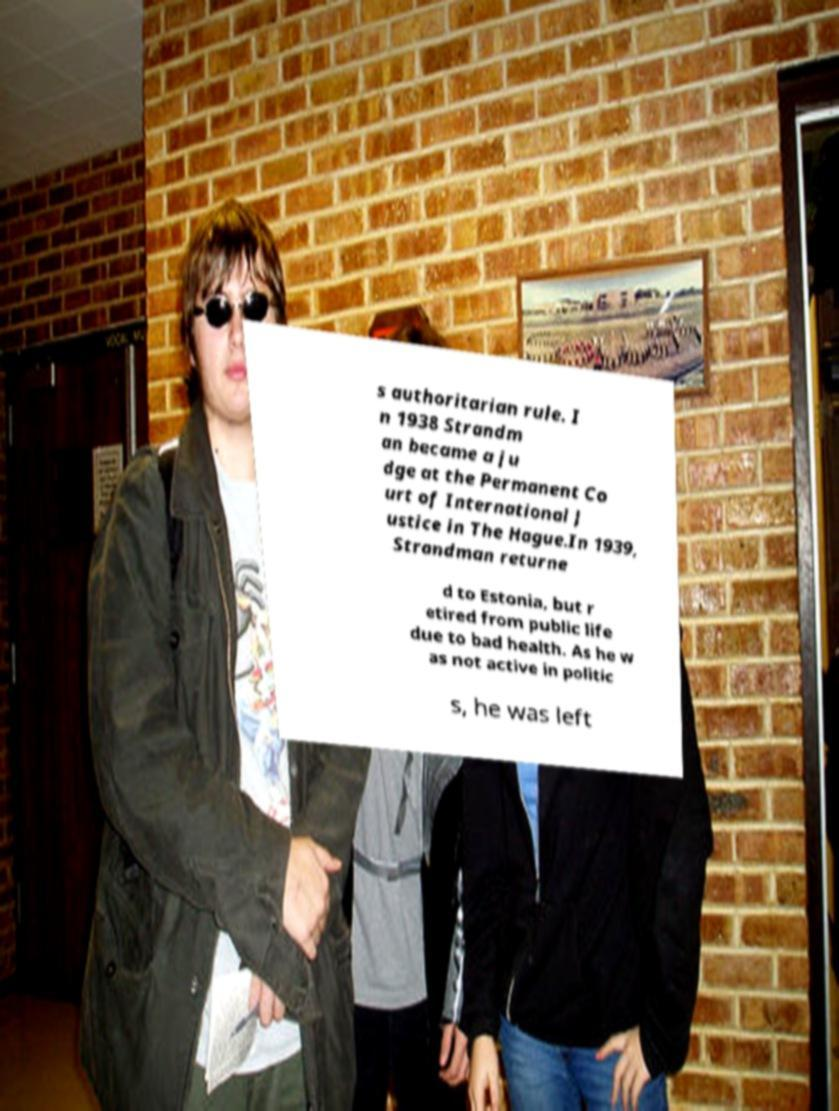I need the written content from this picture converted into text. Can you do that? s authoritarian rule. I n 1938 Strandm an became a ju dge at the Permanent Co urt of International J ustice in The Hague.In 1939, Strandman returne d to Estonia, but r etired from public life due to bad health. As he w as not active in politic s, he was left 